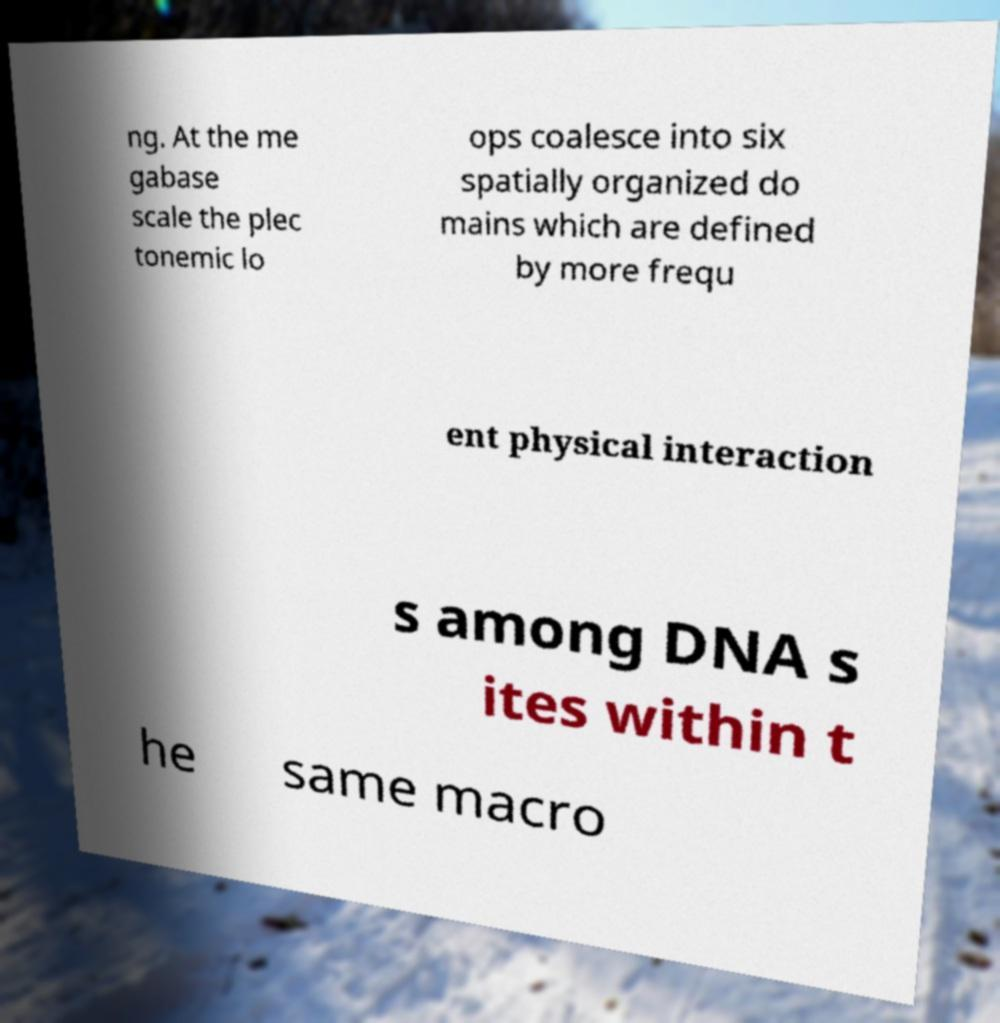What messages or text are displayed in this image? I need them in a readable, typed format. ng. At the me gabase scale the plec tonemic lo ops coalesce into six spatially organized do mains which are defined by more frequ ent physical interaction s among DNA s ites within t he same macro 